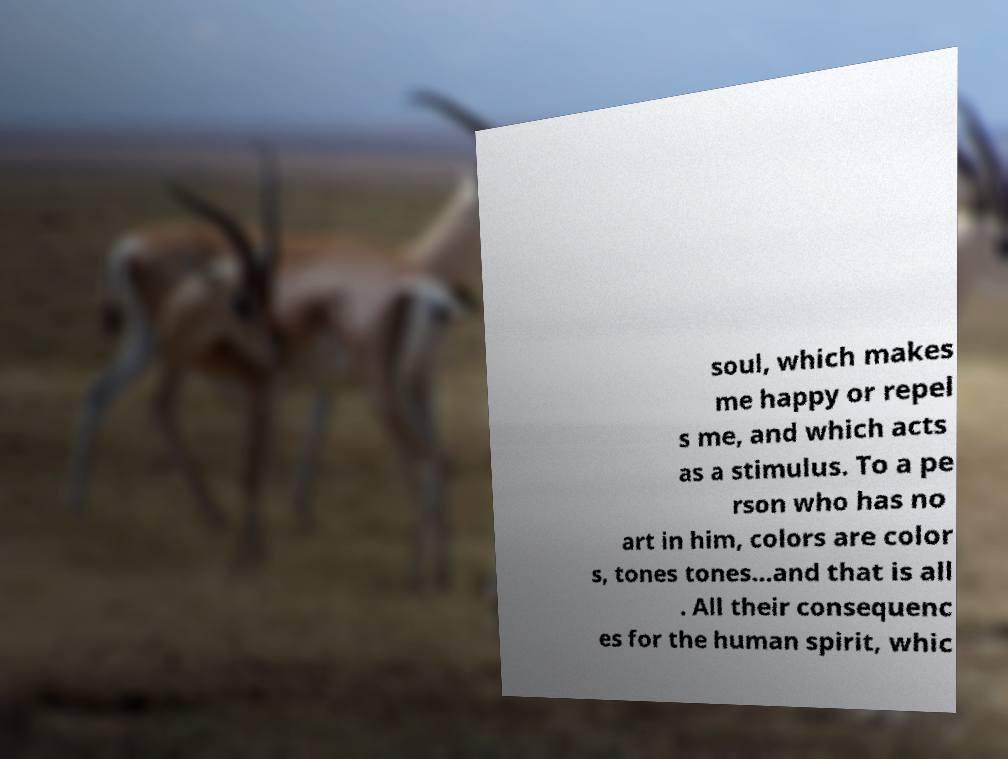Could you assist in decoding the text presented in this image and type it out clearly? soul, which makes me happy or repel s me, and which acts as a stimulus. To a pe rson who has no art in him, colors are color s, tones tones...and that is all . All their consequenc es for the human spirit, whic 